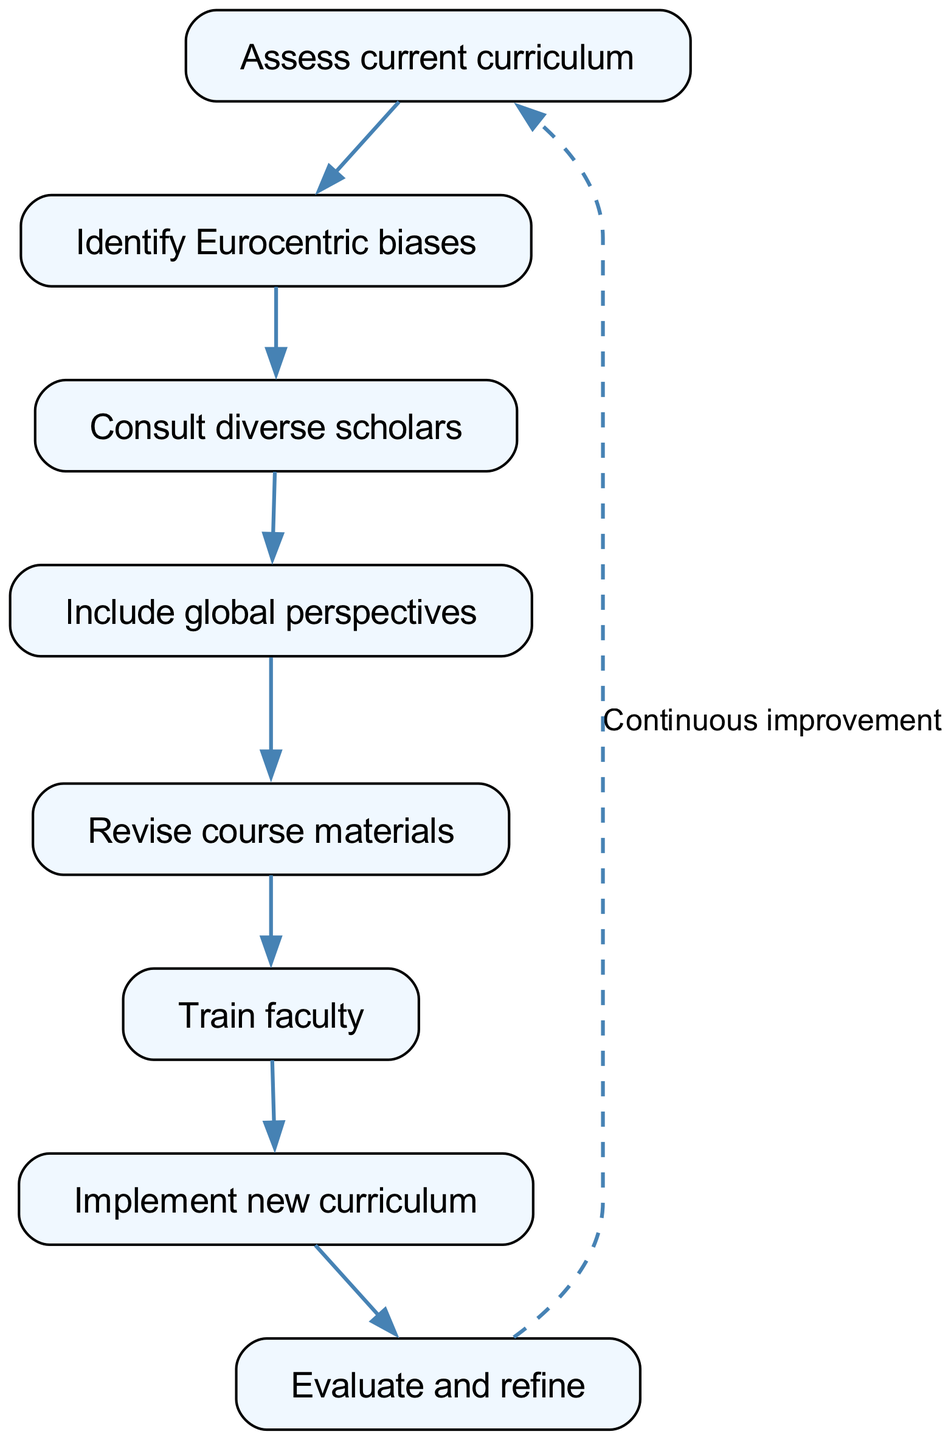What is the first step in the process? The first node in the diagram is labeled "Assess current curriculum," which indicates it is the starting point for the flowchart.
Answer: Assess current curriculum How many nodes are present in the diagram? The data lists a total of 8 nodes that represent various steps in the decolonizing process, which is confirmed by counting the nodes in the diagram.
Answer: 8 What is the last step in the process? The final node in the sequence is labeled "Evaluate and refine," making it the last step of the flowchart.
Answer: Evaluate and refine Which step follows "Consult diverse scholars"? According to the edges in the diagram, "Include global perspectives" directly follows "Consult diverse scholars" as the next step.
Answer: Include global perspectives How many edges connect the nodes? The data specifies 7 edges that illustrate the connections between steps in the process, confirming the flow of the sequence.
Answer: 7 What does the last edge indicate? The final edge that connects "Evaluate and refine" back to "Assess current curriculum" signifies a cycle for continuous improvement in the process, as indicated by the additional text on that edge.
Answer: Continuous improvement Which step directly leads to "Train faculty"? By examining the edges, it is evident that "Revise course materials" is the step that leads directly to "Train faculty."
Answer: Revise course materials What is the relationship between "Identify Eurocentric biases" and "Consult diverse scholars"? "Identify Eurocentric biases" is the preceding step that leads into "Consult diverse scholars," emphasizing that recognizing biases prompts consultation.
Answer: Identify Eurocentric biases 